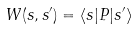Convert formula to latex. <formula><loc_0><loc_0><loc_500><loc_500>W ( s , s ^ { \prime } ) = \langle s | P | s ^ { \prime } \rangle</formula> 